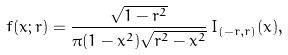<formula> <loc_0><loc_0><loc_500><loc_500>f ( x ; r ) = \frac { \sqrt { 1 - r ^ { 2 } } } { \pi ( 1 - x ^ { 2 } ) \sqrt { r ^ { 2 } - x ^ { 2 } } } \, I _ { ( - r , r ) } ( x ) ,</formula> 